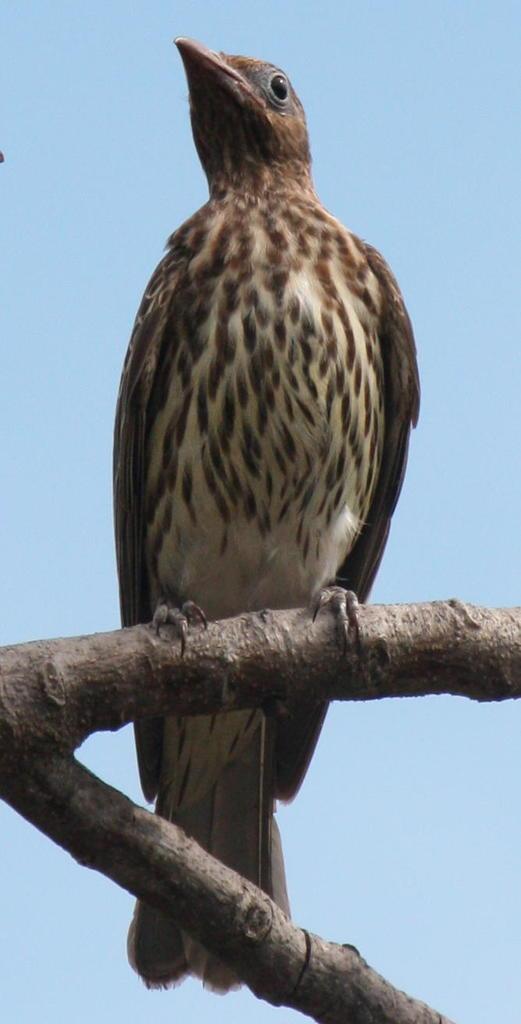In one or two sentences, can you explain what this image depicts? This is a zoomed in picture. In the center there is a bird standing on the branch of a tree. In the background there is a sky. 